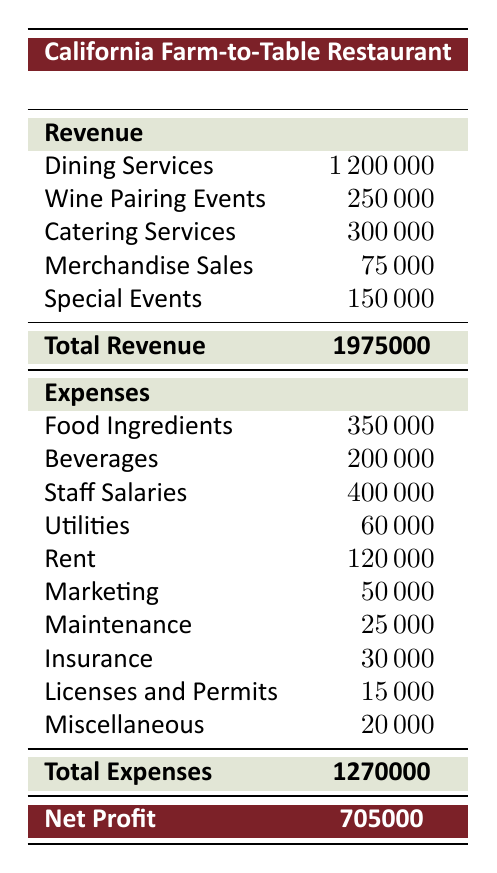What was the total revenue for the restaurant in 2022? The total revenue can be found by looking at the "Total Revenue" row in the Revenue section of the table, which indicates a figure of 1,975,000.
Answer: 1975000 What was the largest source of revenue for the restaurant? By examining the Revenue section, Dining Services accounts for 1,200,000, which is the highest value among the various sources of revenue listed.
Answer: 1200000 What was the total amount spent on staff salaries? The value for staff salaries can be directly found under the Expenses section, where it is listed as 400,000.
Answer: 400000 Did the restaurant have more revenue from wine pairing events or catering services? Looking at the Revenue section, wine pairing events generated 250,000, while catering services brought in 300,000. Since 300,000 is greater than 250,000, catering services had more revenue.
Answer: No What is the difference between total revenue and total expenses? To find this difference, we first look at the Total Revenue (1,975,000) and Total Expenses (1,270,000). Subtracting the total expenses from total revenue: 1,975,000 - 1,270,000 equals 705,000.
Answer: 705000 Was the total expenses for food ingredients greater than that for marketing? The expenses for food ingredients are listed as 350,000, while marketing expenses are 50,000. Since 350,000 is greater than 50,000, the statement is true.
Answer: Yes What is the combined total of utilities and insurance expenses? Utilities expenses are listed at 60,000 and insurance expenses at 30,000. Adding these two amounts together gives us 60,000 + 30,000 = 90,000.
Answer: 90000 What percentage of the total revenue was spent on rent? Rent expenses are provided as 120,000. To find the percentage, we use the formula (rent expense / total revenue) x 100. This becomes (120,000 / 1,975,000) x 100, which approximates to 6.08%.
Answer: 6.08 How much revenue was generated from merchandise sales compared to special events? Revenue from merchandise sales is 75,000, while special events generated 150,000. Comparing these gives us that revenue from special events is double that of merchandise sales.
Answer: No 